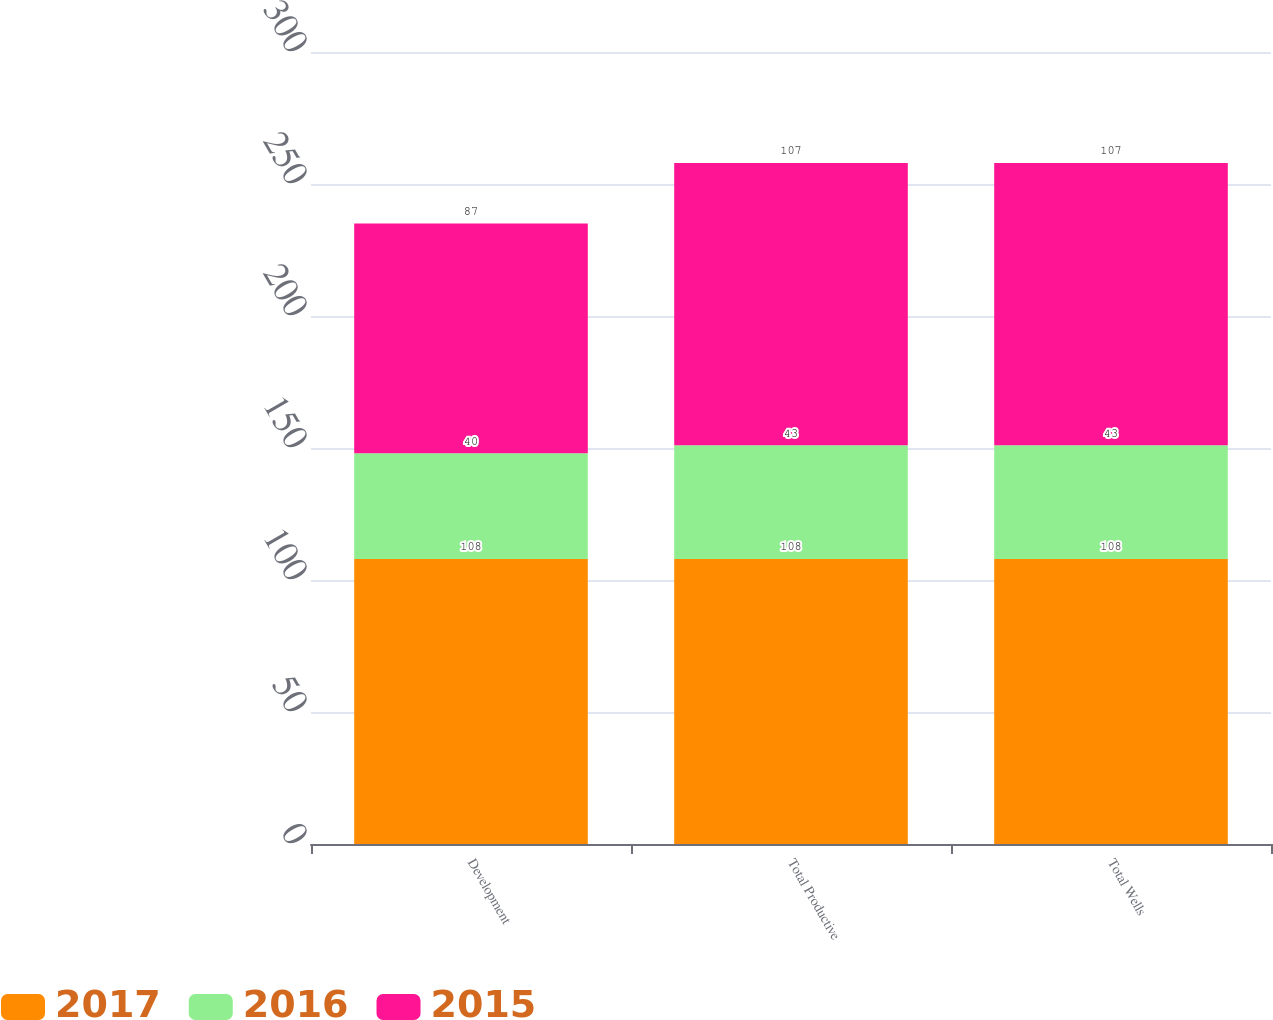Convert chart. <chart><loc_0><loc_0><loc_500><loc_500><stacked_bar_chart><ecel><fcel>Development<fcel>Total Productive<fcel>Total Wells<nl><fcel>2017<fcel>108<fcel>108<fcel>108<nl><fcel>2016<fcel>40<fcel>43<fcel>43<nl><fcel>2015<fcel>87<fcel>107<fcel>107<nl></chart> 